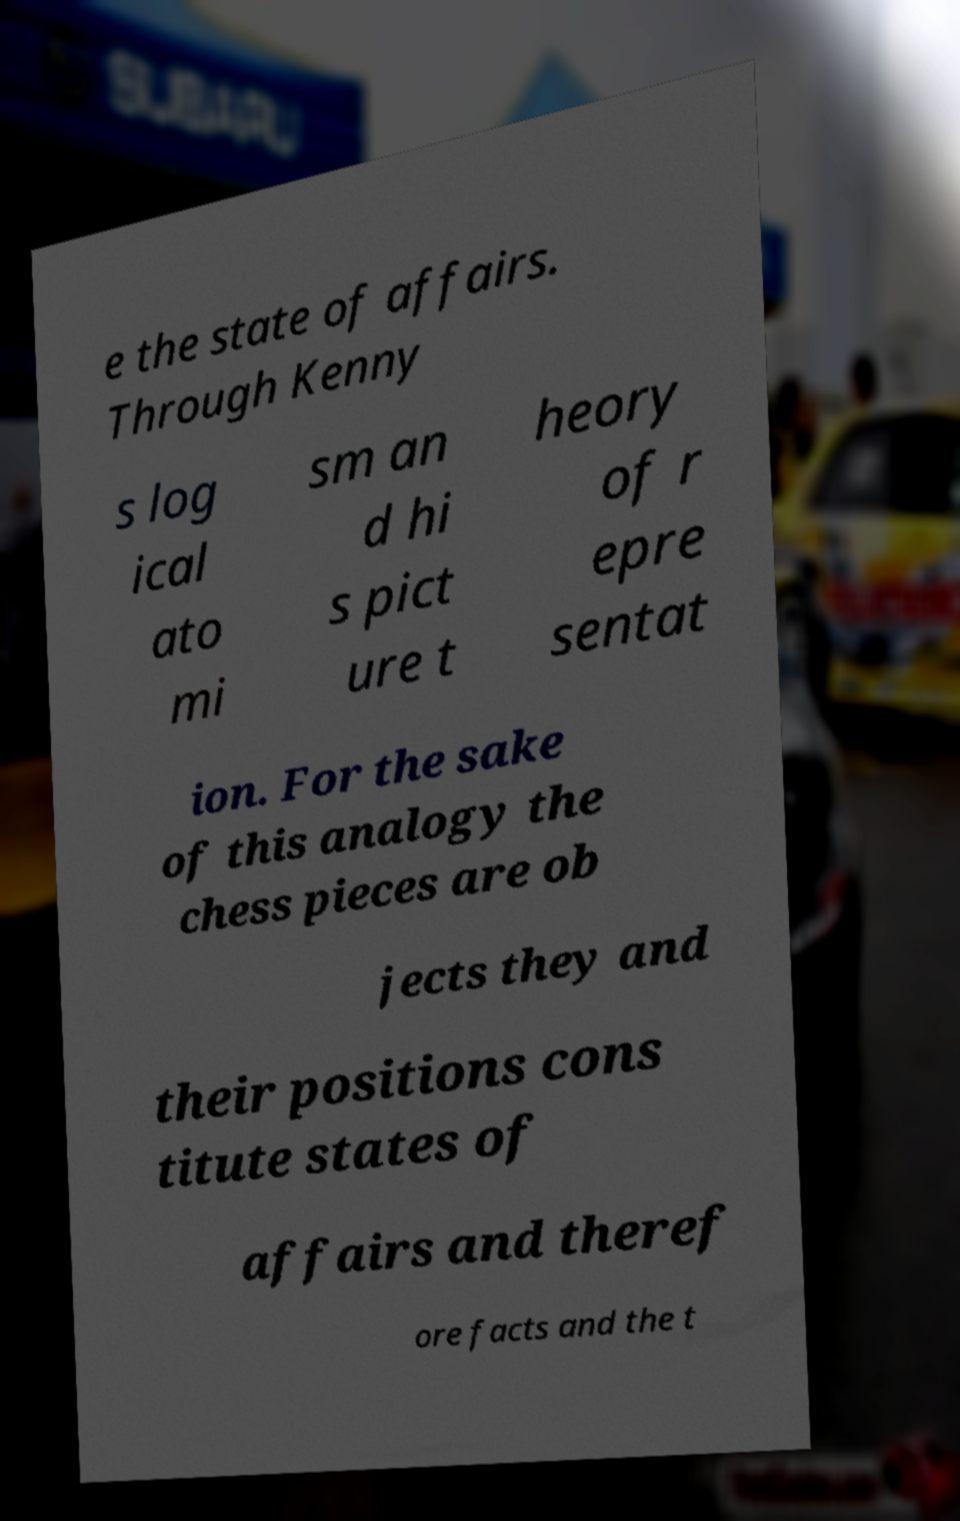What messages or text are displayed in this image? I need them in a readable, typed format. e the state of affairs. Through Kenny s log ical ato mi sm an d hi s pict ure t heory of r epre sentat ion. For the sake of this analogy the chess pieces are ob jects they and their positions cons titute states of affairs and theref ore facts and the t 